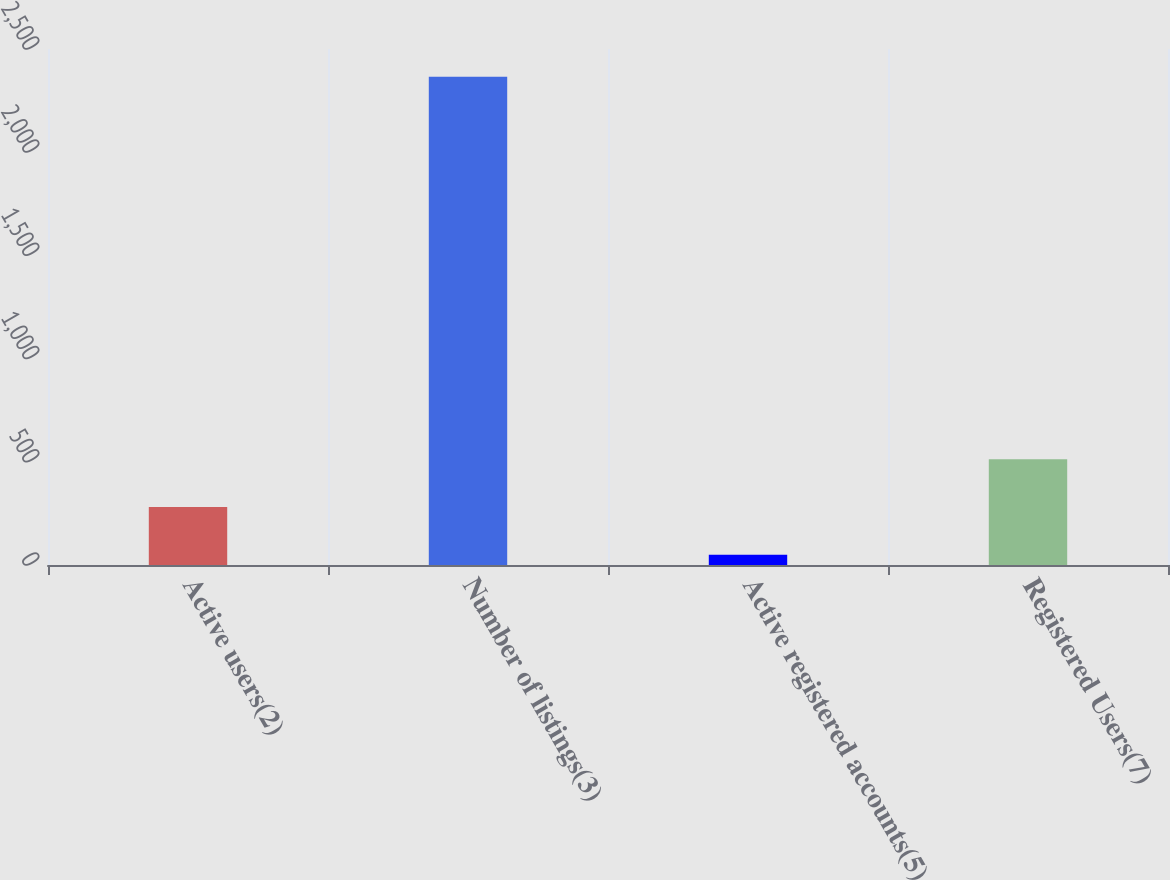Convert chart to OTSL. <chart><loc_0><loc_0><loc_500><loc_500><bar_chart><fcel>Active users(2)<fcel>Number of listings(3)<fcel>Active registered accounts(5)<fcel>Registered Users(7)<nl><fcel>280.99<fcel>2365.3<fcel>49.4<fcel>512.58<nl></chart> 